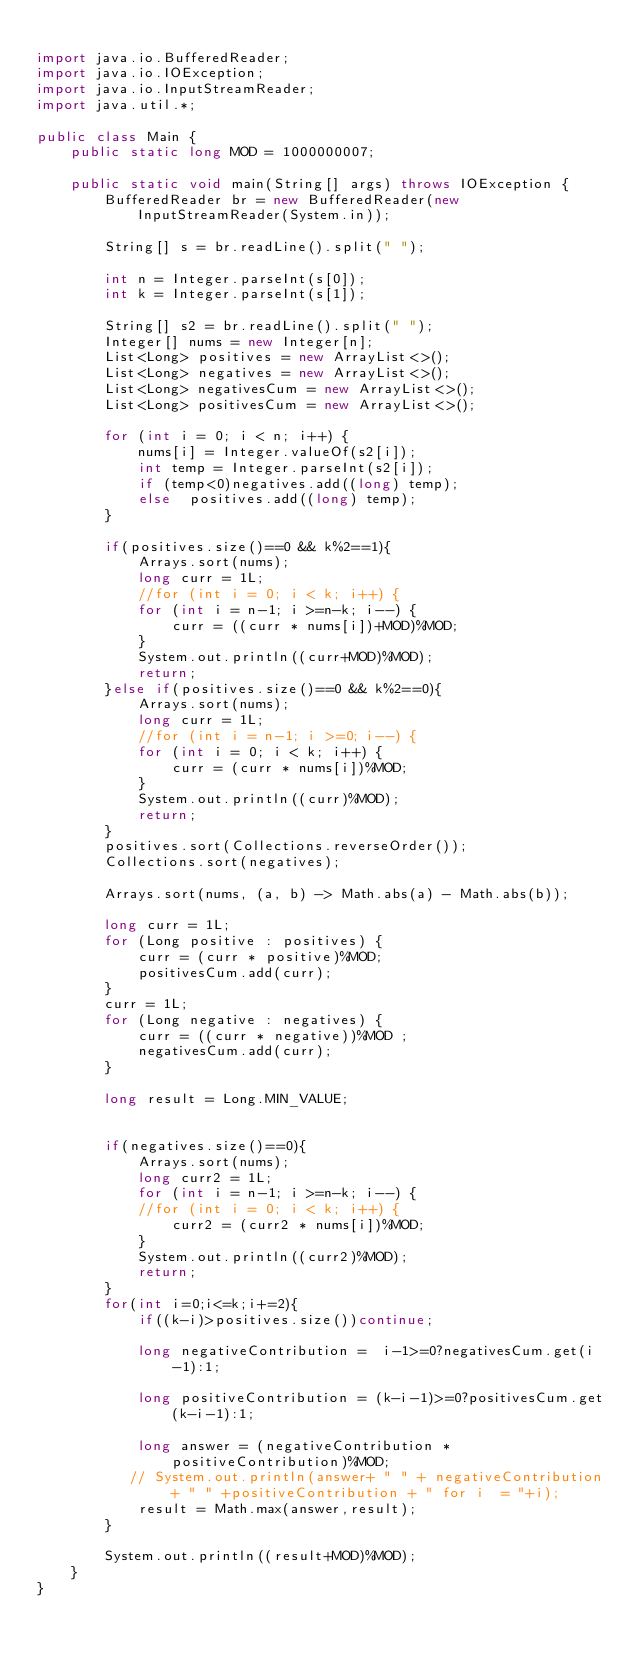Convert code to text. <code><loc_0><loc_0><loc_500><loc_500><_Java_>
import java.io.BufferedReader;
import java.io.IOException;
import java.io.InputStreamReader;
import java.util.*;

public class Main {
    public static long MOD = 1000000007;

    public static void main(String[] args) throws IOException {
        BufferedReader br = new BufferedReader(new InputStreamReader(System.in));

        String[] s = br.readLine().split(" ");

        int n = Integer.parseInt(s[0]);
        int k = Integer.parseInt(s[1]);

        String[] s2 = br.readLine().split(" ");
        Integer[] nums = new Integer[n];
        List<Long> positives = new ArrayList<>();
        List<Long> negatives = new ArrayList<>();
        List<Long> negativesCum = new ArrayList<>();
        List<Long> positivesCum = new ArrayList<>();

        for (int i = 0; i < n; i++) {
            nums[i] = Integer.valueOf(s2[i]);
            int temp = Integer.parseInt(s2[i]);
            if (temp<0)negatives.add((long) temp);
            else  positives.add((long) temp);
        }

        if(positives.size()==0 && k%2==1){
            Arrays.sort(nums);
            long curr = 1L;
            //for (int i = 0; i < k; i++) {
            for (int i = n-1; i >=n-k; i--) {
                curr = ((curr * nums[i])+MOD)%MOD;
            }
            System.out.println((curr+MOD)%MOD);
            return;
        }else if(positives.size()==0 && k%2==0){
            Arrays.sort(nums);
            long curr = 1L;
            //for (int i = n-1; i >=0; i--) {
            for (int i = 0; i < k; i++) {
                curr = (curr * nums[i])%MOD;
            }
            System.out.println((curr)%MOD);
            return;
        }
        positives.sort(Collections.reverseOrder());
        Collections.sort(negatives);

        Arrays.sort(nums, (a, b) -> Math.abs(a) - Math.abs(b));

        long curr = 1L;
        for (Long positive : positives) {
            curr = (curr * positive)%MOD;
            positivesCum.add(curr);
        }
        curr = 1L;
        for (Long negative : negatives) {
            curr = ((curr * negative))%MOD ;
            negativesCum.add(curr);
        }

        long result = Long.MIN_VALUE;


        if(negatives.size()==0){
            Arrays.sort(nums);
            long curr2 = 1L;
            for (int i = n-1; i >=n-k; i--) {
            //for (int i = 0; i < k; i++) {
                curr2 = (curr2 * nums[i])%MOD;
            }
            System.out.println((curr2)%MOD);
            return;
        }
        for(int i=0;i<=k;i+=2){
            if((k-i)>positives.size())continue;

            long negativeContribution =  i-1>=0?negativesCum.get(i-1):1;

            long positiveContribution = (k-i-1)>=0?positivesCum.get(k-i-1):1;

            long answer = (negativeContribution * positiveContribution)%MOD;
           // System.out.println(answer+ " " + negativeContribution + " " +positiveContribution + " for i  = "+i);
            result = Math.max(answer,result);
        }

        System.out.println((result+MOD)%MOD);
    }
}</code> 